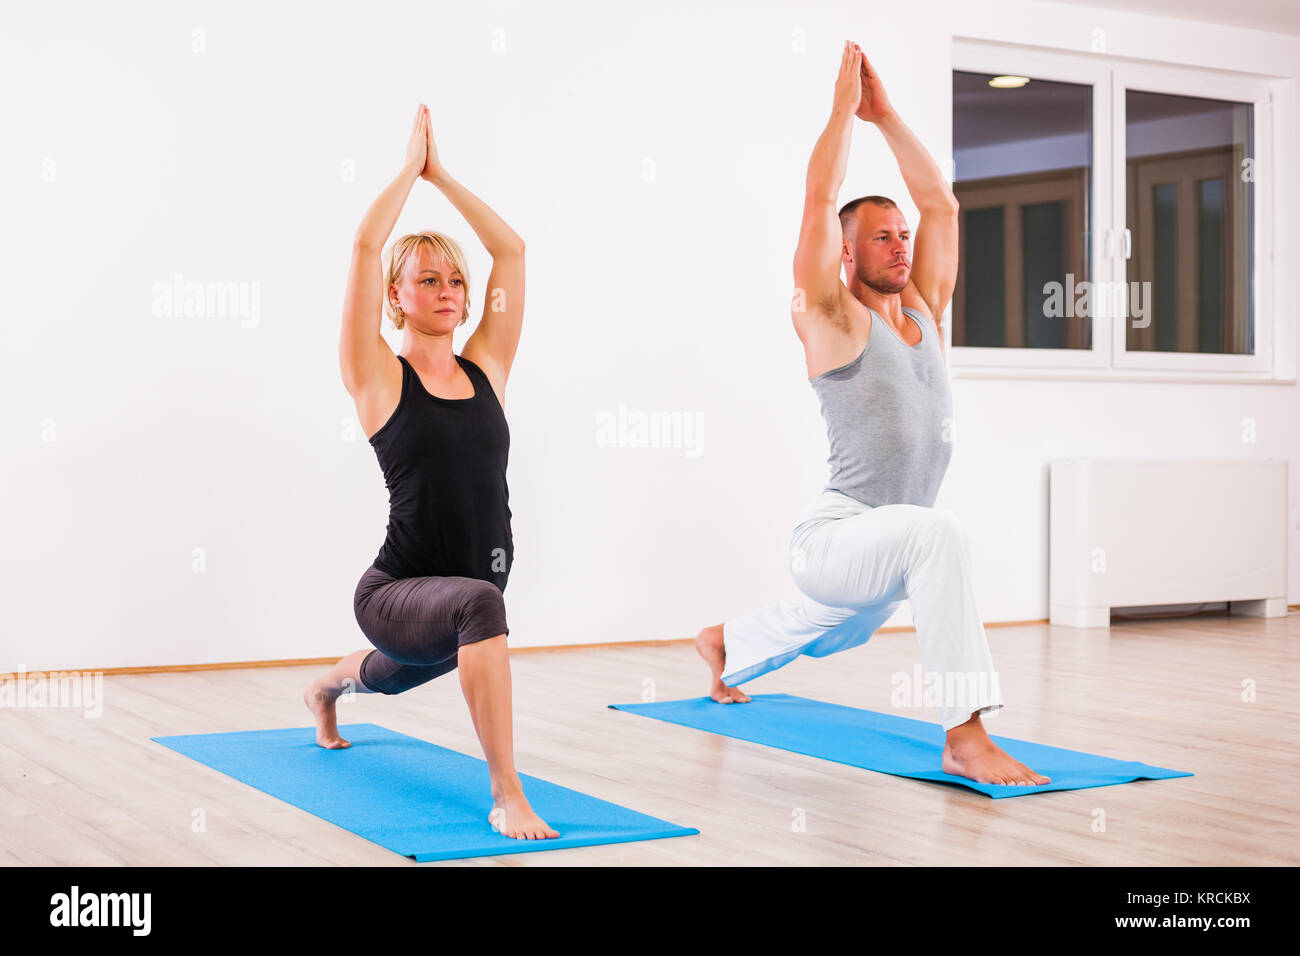Can you tell me more about the setting in which these individuals are practicing yoga? The bright and minimalistic setting creates an inviting atmosphere for yoga practice. The spacious room features clean white walls and large windows that allow plenty of natural light to enhance the serenity of the space. Practicing in such a clean, uncluttered space can help in maintaining focus, reducing distractions and making the most of the yoga session. 